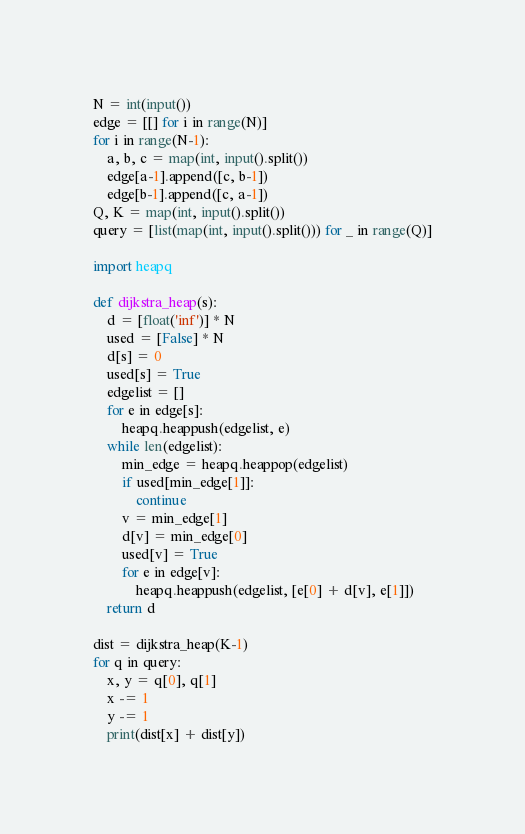Convert code to text. <code><loc_0><loc_0><loc_500><loc_500><_Python_>N = int(input())
edge = [[] for i in range(N)]
for i in range(N-1):
    a, b, c = map(int, input().split())
    edge[a-1].append([c, b-1])
    edge[b-1].append([c, a-1])
Q, K = map(int, input().split())
query = [list(map(int, input().split())) for _ in range(Q)]

import heapq

def dijkstra_heap(s):
    d = [float('inf')] * N
    used = [False] * N
    d[s] = 0
    used[s] = True
    edgelist = []
    for e in edge[s]:
        heapq.heappush(edgelist, e)
    while len(edgelist):
        min_edge = heapq.heappop(edgelist)
        if used[min_edge[1]]:
            continue
        v = min_edge[1]
        d[v] = min_edge[0]
        used[v] = True
        for e in edge[v]:
            heapq.heappush(edgelist, [e[0] + d[v], e[1]])
    return d

dist = dijkstra_heap(K-1)
for q in query:
    x, y = q[0], q[1]
    x -= 1
    y -= 1
    print(dist[x] + dist[y])</code> 